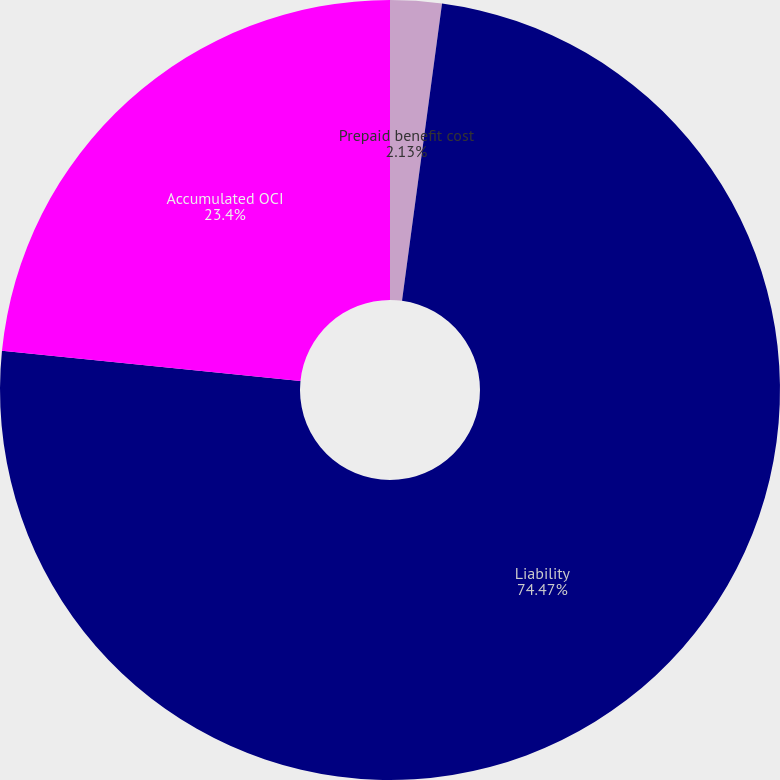Convert chart to OTSL. <chart><loc_0><loc_0><loc_500><loc_500><pie_chart><fcel>Prepaid benefit cost<fcel>Liability<fcel>Accumulated OCI<nl><fcel>2.13%<fcel>74.47%<fcel>23.4%<nl></chart> 